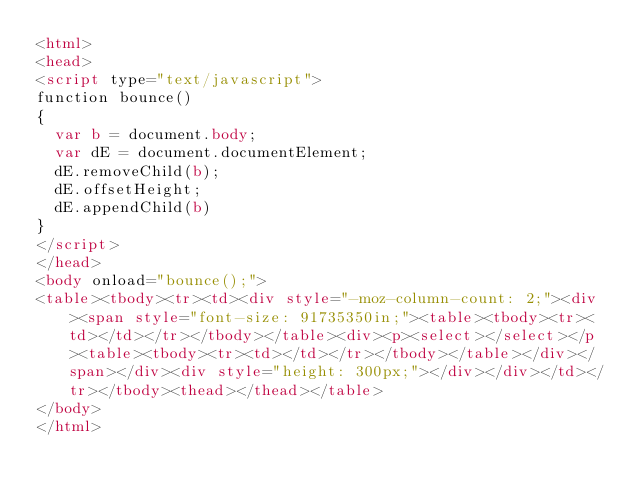Convert code to text. <code><loc_0><loc_0><loc_500><loc_500><_HTML_><html>
<head>
<script type="text/javascript">
function bounce()
{
  var b = document.body;
  var dE = document.documentElement;
  dE.removeChild(b);
  dE.offsetHeight;
  dE.appendChild(b)
}
</script>
</head>
<body onload="bounce();">
<table><tbody><tr><td><div style="-moz-column-count: 2;"><div><span style="font-size: 91735350in;"><table><tbody><tr><td></td></tr></tbody></table><div><p><select></select></p><table><tbody><tr><td></td></tr></tbody></table></div></span></div><div style="height: 300px;"></div></div></td></tr></tbody><thead></thead></table>
</body>
</html>
</code> 